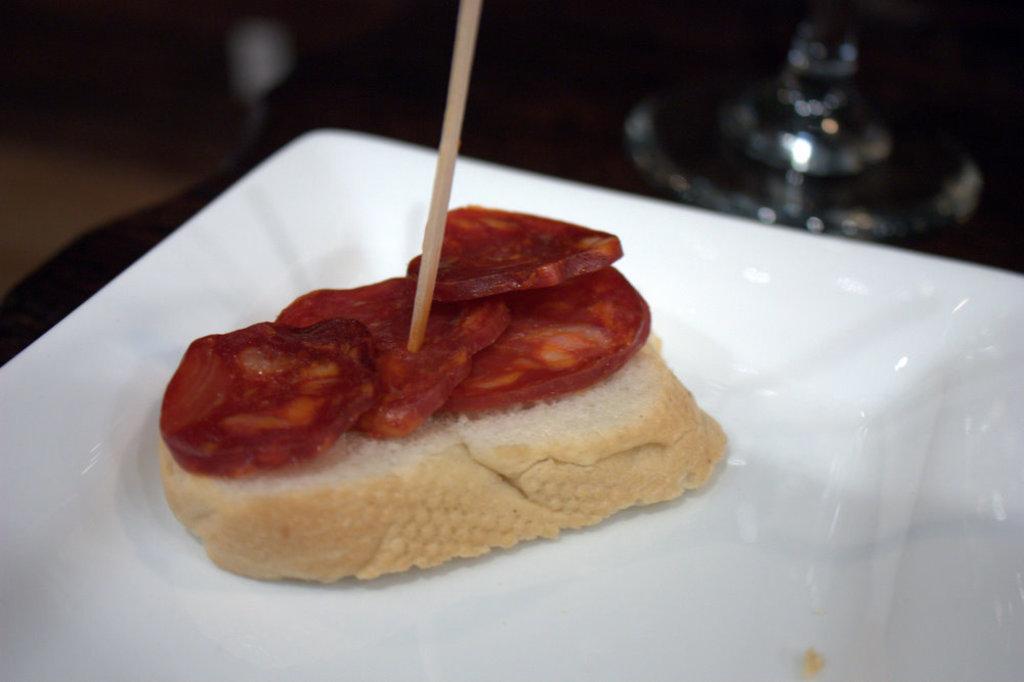Can you describe this image briefly? In this image there is a sandwich with a toothpick on the plate, and there is blur background. 